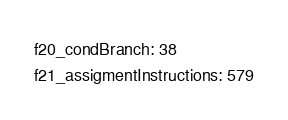Convert code to text. <code><loc_0><loc_0><loc_500><loc_500><_YAML_>f20_condBranch: 38
f21_assigmentInstructions: 579</code> 